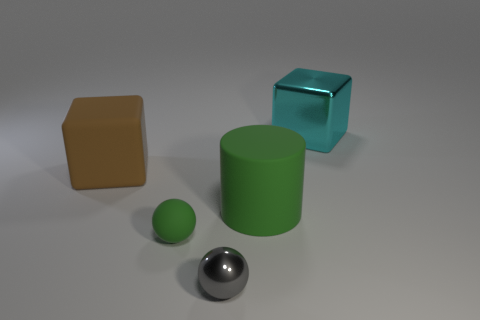Subtract all gray spheres. How many spheres are left? 1 Subtract all blocks. How many objects are left? 3 Add 2 big gray cubes. How many objects exist? 7 Subtract all cyan cylinders. Subtract all purple spheres. How many cylinders are left? 1 Subtract all green balls. How many brown cylinders are left? 0 Subtract all metallic cubes. Subtract all gray metal objects. How many objects are left? 3 Add 1 small gray things. How many small gray things are left? 2 Add 3 brown objects. How many brown objects exist? 4 Subtract 0 purple cylinders. How many objects are left? 5 Subtract 1 cubes. How many cubes are left? 1 